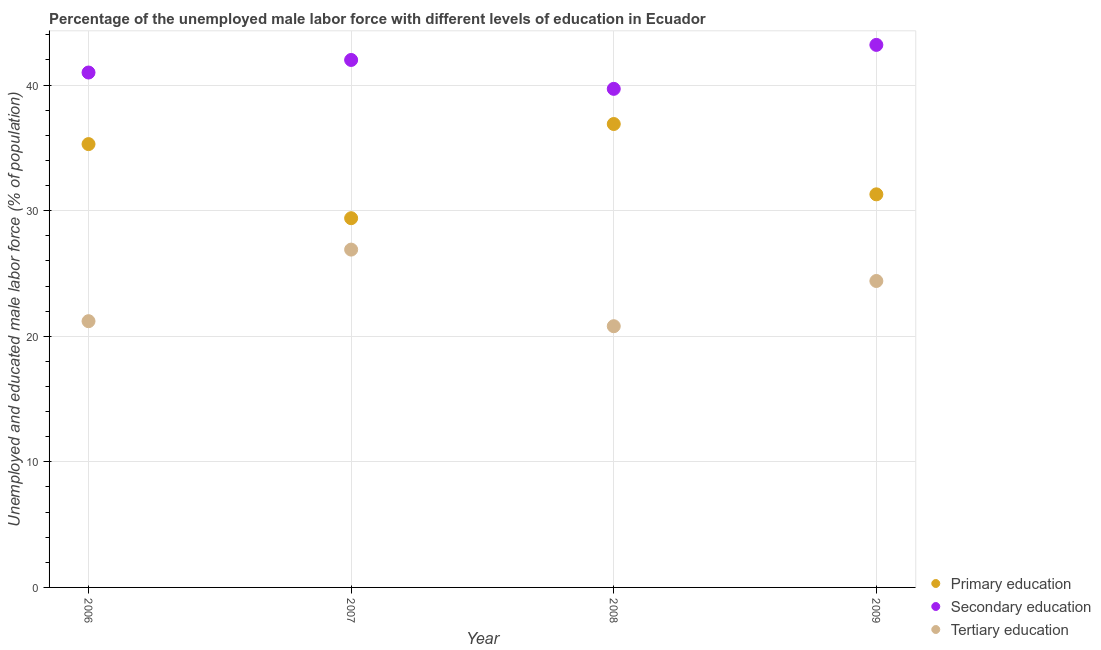Is the number of dotlines equal to the number of legend labels?
Offer a terse response. Yes. What is the percentage of male labor force who received tertiary education in 2007?
Your answer should be very brief. 26.9. Across all years, what is the maximum percentage of male labor force who received primary education?
Ensure brevity in your answer.  36.9. Across all years, what is the minimum percentage of male labor force who received primary education?
Offer a terse response. 29.4. In which year was the percentage of male labor force who received secondary education maximum?
Offer a terse response. 2009. In which year was the percentage of male labor force who received tertiary education minimum?
Ensure brevity in your answer.  2008. What is the total percentage of male labor force who received secondary education in the graph?
Provide a short and direct response. 165.9. What is the difference between the percentage of male labor force who received tertiary education in 2006 and that in 2008?
Your answer should be very brief. 0.4. What is the difference between the percentage of male labor force who received secondary education in 2008 and the percentage of male labor force who received primary education in 2009?
Provide a short and direct response. 8.4. What is the average percentage of male labor force who received tertiary education per year?
Your response must be concise. 23.32. In the year 2007, what is the difference between the percentage of male labor force who received tertiary education and percentage of male labor force who received secondary education?
Your answer should be very brief. -15.1. In how many years, is the percentage of male labor force who received secondary education greater than 10 %?
Provide a short and direct response. 4. What is the ratio of the percentage of male labor force who received tertiary education in 2006 to that in 2008?
Make the answer very short. 1.02. Is the percentage of male labor force who received tertiary education in 2007 less than that in 2008?
Your response must be concise. No. Is the difference between the percentage of male labor force who received tertiary education in 2007 and 2008 greater than the difference between the percentage of male labor force who received primary education in 2007 and 2008?
Your response must be concise. Yes. What is the difference between the highest and the second highest percentage of male labor force who received tertiary education?
Ensure brevity in your answer.  2.5. What is the difference between the highest and the lowest percentage of male labor force who received primary education?
Provide a short and direct response. 7.5. Is it the case that in every year, the sum of the percentage of male labor force who received primary education and percentage of male labor force who received secondary education is greater than the percentage of male labor force who received tertiary education?
Make the answer very short. Yes. Does the percentage of male labor force who received primary education monotonically increase over the years?
Offer a terse response. No. Does the graph contain any zero values?
Keep it short and to the point. No. How many legend labels are there?
Ensure brevity in your answer.  3. What is the title of the graph?
Provide a succinct answer. Percentage of the unemployed male labor force with different levels of education in Ecuador. What is the label or title of the X-axis?
Provide a short and direct response. Year. What is the label or title of the Y-axis?
Your answer should be compact. Unemployed and educated male labor force (% of population). What is the Unemployed and educated male labor force (% of population) in Primary education in 2006?
Offer a terse response. 35.3. What is the Unemployed and educated male labor force (% of population) in Secondary education in 2006?
Your response must be concise. 41. What is the Unemployed and educated male labor force (% of population) of Tertiary education in 2006?
Ensure brevity in your answer.  21.2. What is the Unemployed and educated male labor force (% of population) of Primary education in 2007?
Offer a terse response. 29.4. What is the Unemployed and educated male labor force (% of population) in Secondary education in 2007?
Offer a terse response. 42. What is the Unemployed and educated male labor force (% of population) of Tertiary education in 2007?
Your response must be concise. 26.9. What is the Unemployed and educated male labor force (% of population) of Primary education in 2008?
Keep it short and to the point. 36.9. What is the Unemployed and educated male labor force (% of population) of Secondary education in 2008?
Keep it short and to the point. 39.7. What is the Unemployed and educated male labor force (% of population) in Tertiary education in 2008?
Your response must be concise. 20.8. What is the Unemployed and educated male labor force (% of population) of Primary education in 2009?
Keep it short and to the point. 31.3. What is the Unemployed and educated male labor force (% of population) in Secondary education in 2009?
Provide a short and direct response. 43.2. What is the Unemployed and educated male labor force (% of population) in Tertiary education in 2009?
Provide a succinct answer. 24.4. Across all years, what is the maximum Unemployed and educated male labor force (% of population) in Primary education?
Make the answer very short. 36.9. Across all years, what is the maximum Unemployed and educated male labor force (% of population) of Secondary education?
Ensure brevity in your answer.  43.2. Across all years, what is the maximum Unemployed and educated male labor force (% of population) in Tertiary education?
Provide a short and direct response. 26.9. Across all years, what is the minimum Unemployed and educated male labor force (% of population) of Primary education?
Your response must be concise. 29.4. Across all years, what is the minimum Unemployed and educated male labor force (% of population) in Secondary education?
Make the answer very short. 39.7. Across all years, what is the minimum Unemployed and educated male labor force (% of population) of Tertiary education?
Give a very brief answer. 20.8. What is the total Unemployed and educated male labor force (% of population) in Primary education in the graph?
Your response must be concise. 132.9. What is the total Unemployed and educated male labor force (% of population) of Secondary education in the graph?
Your answer should be very brief. 165.9. What is the total Unemployed and educated male labor force (% of population) in Tertiary education in the graph?
Give a very brief answer. 93.3. What is the difference between the Unemployed and educated male labor force (% of population) of Primary education in 2006 and that in 2007?
Provide a succinct answer. 5.9. What is the difference between the Unemployed and educated male labor force (% of population) in Secondary education in 2006 and that in 2007?
Offer a terse response. -1. What is the difference between the Unemployed and educated male labor force (% of population) of Tertiary education in 2006 and that in 2009?
Your answer should be very brief. -3.2. What is the difference between the Unemployed and educated male labor force (% of population) in Secondary education in 2007 and that in 2008?
Ensure brevity in your answer.  2.3. What is the difference between the Unemployed and educated male labor force (% of population) of Primary education in 2007 and that in 2009?
Offer a terse response. -1.9. What is the difference between the Unemployed and educated male labor force (% of population) of Secondary education in 2007 and that in 2009?
Make the answer very short. -1.2. What is the difference between the Unemployed and educated male labor force (% of population) in Primary education in 2008 and that in 2009?
Provide a succinct answer. 5.6. What is the difference between the Unemployed and educated male labor force (% of population) of Tertiary education in 2008 and that in 2009?
Provide a succinct answer. -3.6. What is the difference between the Unemployed and educated male labor force (% of population) in Primary education in 2006 and the Unemployed and educated male labor force (% of population) in Tertiary education in 2007?
Your response must be concise. 8.4. What is the difference between the Unemployed and educated male labor force (% of population) in Primary education in 2006 and the Unemployed and educated male labor force (% of population) in Secondary education in 2008?
Offer a terse response. -4.4. What is the difference between the Unemployed and educated male labor force (% of population) of Primary education in 2006 and the Unemployed and educated male labor force (% of population) of Tertiary education in 2008?
Give a very brief answer. 14.5. What is the difference between the Unemployed and educated male labor force (% of population) of Secondary education in 2006 and the Unemployed and educated male labor force (% of population) of Tertiary education in 2008?
Ensure brevity in your answer.  20.2. What is the difference between the Unemployed and educated male labor force (% of population) in Primary education in 2006 and the Unemployed and educated male labor force (% of population) in Secondary education in 2009?
Ensure brevity in your answer.  -7.9. What is the difference between the Unemployed and educated male labor force (% of population) in Primary education in 2006 and the Unemployed and educated male labor force (% of population) in Tertiary education in 2009?
Provide a short and direct response. 10.9. What is the difference between the Unemployed and educated male labor force (% of population) of Secondary education in 2007 and the Unemployed and educated male labor force (% of population) of Tertiary education in 2008?
Make the answer very short. 21.2. What is the difference between the Unemployed and educated male labor force (% of population) of Primary education in 2008 and the Unemployed and educated male labor force (% of population) of Tertiary education in 2009?
Your response must be concise. 12.5. What is the difference between the Unemployed and educated male labor force (% of population) in Secondary education in 2008 and the Unemployed and educated male labor force (% of population) in Tertiary education in 2009?
Your answer should be compact. 15.3. What is the average Unemployed and educated male labor force (% of population) of Primary education per year?
Provide a short and direct response. 33.23. What is the average Unemployed and educated male labor force (% of population) of Secondary education per year?
Your answer should be compact. 41.48. What is the average Unemployed and educated male labor force (% of population) in Tertiary education per year?
Ensure brevity in your answer.  23.32. In the year 2006, what is the difference between the Unemployed and educated male labor force (% of population) of Secondary education and Unemployed and educated male labor force (% of population) of Tertiary education?
Offer a terse response. 19.8. In the year 2007, what is the difference between the Unemployed and educated male labor force (% of population) in Primary education and Unemployed and educated male labor force (% of population) in Tertiary education?
Provide a succinct answer. 2.5. In the year 2008, what is the difference between the Unemployed and educated male labor force (% of population) in Primary education and Unemployed and educated male labor force (% of population) in Tertiary education?
Ensure brevity in your answer.  16.1. In the year 2009, what is the difference between the Unemployed and educated male labor force (% of population) of Primary education and Unemployed and educated male labor force (% of population) of Secondary education?
Your answer should be compact. -11.9. What is the ratio of the Unemployed and educated male labor force (% of population) in Primary education in 2006 to that in 2007?
Offer a terse response. 1.2. What is the ratio of the Unemployed and educated male labor force (% of population) in Secondary education in 2006 to that in 2007?
Your answer should be compact. 0.98. What is the ratio of the Unemployed and educated male labor force (% of population) of Tertiary education in 2006 to that in 2007?
Ensure brevity in your answer.  0.79. What is the ratio of the Unemployed and educated male labor force (% of population) of Primary education in 2006 to that in 2008?
Provide a short and direct response. 0.96. What is the ratio of the Unemployed and educated male labor force (% of population) in Secondary education in 2006 to that in 2008?
Provide a short and direct response. 1.03. What is the ratio of the Unemployed and educated male labor force (% of population) in Tertiary education in 2006 to that in 2008?
Provide a succinct answer. 1.02. What is the ratio of the Unemployed and educated male labor force (% of population) of Primary education in 2006 to that in 2009?
Offer a terse response. 1.13. What is the ratio of the Unemployed and educated male labor force (% of population) of Secondary education in 2006 to that in 2009?
Keep it short and to the point. 0.95. What is the ratio of the Unemployed and educated male labor force (% of population) in Tertiary education in 2006 to that in 2009?
Keep it short and to the point. 0.87. What is the ratio of the Unemployed and educated male labor force (% of population) in Primary education in 2007 to that in 2008?
Make the answer very short. 0.8. What is the ratio of the Unemployed and educated male labor force (% of population) of Secondary education in 2007 to that in 2008?
Your answer should be compact. 1.06. What is the ratio of the Unemployed and educated male labor force (% of population) in Tertiary education in 2007 to that in 2008?
Your answer should be very brief. 1.29. What is the ratio of the Unemployed and educated male labor force (% of population) of Primary education in 2007 to that in 2009?
Keep it short and to the point. 0.94. What is the ratio of the Unemployed and educated male labor force (% of population) in Secondary education in 2007 to that in 2009?
Make the answer very short. 0.97. What is the ratio of the Unemployed and educated male labor force (% of population) in Tertiary education in 2007 to that in 2009?
Provide a succinct answer. 1.1. What is the ratio of the Unemployed and educated male labor force (% of population) of Primary education in 2008 to that in 2009?
Keep it short and to the point. 1.18. What is the ratio of the Unemployed and educated male labor force (% of population) in Secondary education in 2008 to that in 2009?
Offer a terse response. 0.92. What is the ratio of the Unemployed and educated male labor force (% of population) of Tertiary education in 2008 to that in 2009?
Provide a short and direct response. 0.85. What is the difference between the highest and the second highest Unemployed and educated male labor force (% of population) of Primary education?
Provide a short and direct response. 1.6. What is the difference between the highest and the second highest Unemployed and educated male labor force (% of population) in Tertiary education?
Ensure brevity in your answer.  2.5. What is the difference between the highest and the lowest Unemployed and educated male labor force (% of population) in Tertiary education?
Your answer should be compact. 6.1. 